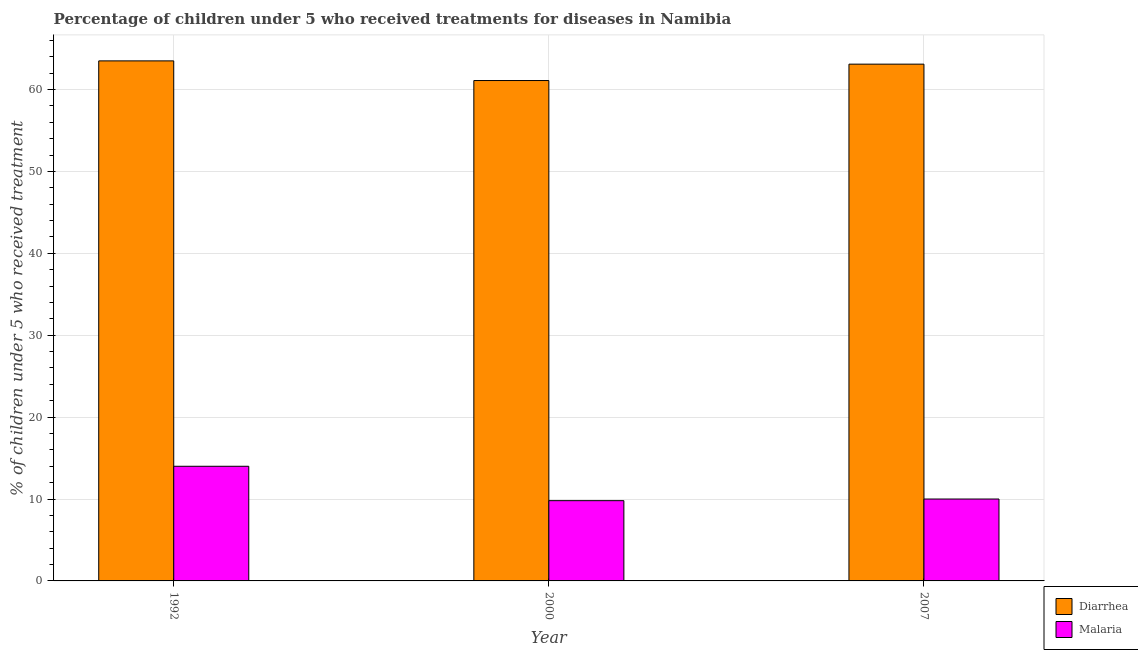How many different coloured bars are there?
Your answer should be very brief. 2. How many groups of bars are there?
Offer a terse response. 3. Are the number of bars per tick equal to the number of legend labels?
Your response must be concise. Yes. Are the number of bars on each tick of the X-axis equal?
Make the answer very short. Yes. What is the label of the 2nd group of bars from the left?
Ensure brevity in your answer.  2000. What is the percentage of children who received treatment for diarrhoea in 2000?
Your answer should be compact. 61.1. Across all years, what is the maximum percentage of children who received treatment for diarrhoea?
Keep it short and to the point. 63.5. Across all years, what is the minimum percentage of children who received treatment for diarrhoea?
Offer a terse response. 61.1. What is the total percentage of children who received treatment for diarrhoea in the graph?
Provide a short and direct response. 187.7. What is the difference between the percentage of children who received treatment for diarrhoea in 1992 and that in 2000?
Offer a terse response. 2.4. What is the difference between the percentage of children who received treatment for malaria in 2000 and the percentage of children who received treatment for diarrhoea in 1992?
Keep it short and to the point. -4.2. What is the average percentage of children who received treatment for diarrhoea per year?
Ensure brevity in your answer.  62.57. In the year 2007, what is the difference between the percentage of children who received treatment for malaria and percentage of children who received treatment for diarrhoea?
Provide a short and direct response. 0. In how many years, is the percentage of children who received treatment for diarrhoea greater than 4 %?
Your response must be concise. 3. What is the ratio of the percentage of children who received treatment for diarrhoea in 1992 to that in 2000?
Keep it short and to the point. 1.04. What is the difference between the highest and the second highest percentage of children who received treatment for diarrhoea?
Give a very brief answer. 0.4. What is the difference between the highest and the lowest percentage of children who received treatment for diarrhoea?
Ensure brevity in your answer.  2.4. In how many years, is the percentage of children who received treatment for malaria greater than the average percentage of children who received treatment for malaria taken over all years?
Your answer should be compact. 1. What does the 1st bar from the left in 2007 represents?
Your response must be concise. Diarrhea. What does the 2nd bar from the right in 2007 represents?
Provide a succinct answer. Diarrhea. Are all the bars in the graph horizontal?
Offer a terse response. No. How many years are there in the graph?
Offer a very short reply. 3. What is the difference between two consecutive major ticks on the Y-axis?
Offer a very short reply. 10. Are the values on the major ticks of Y-axis written in scientific E-notation?
Give a very brief answer. No. How many legend labels are there?
Offer a terse response. 2. How are the legend labels stacked?
Provide a succinct answer. Vertical. What is the title of the graph?
Offer a terse response. Percentage of children under 5 who received treatments for diseases in Namibia. Does "Lower secondary education" appear as one of the legend labels in the graph?
Your answer should be compact. No. What is the label or title of the X-axis?
Provide a short and direct response. Year. What is the label or title of the Y-axis?
Make the answer very short. % of children under 5 who received treatment. What is the % of children under 5 who received treatment of Diarrhea in 1992?
Keep it short and to the point. 63.5. What is the % of children under 5 who received treatment in Malaria in 1992?
Ensure brevity in your answer.  14. What is the % of children under 5 who received treatment of Diarrhea in 2000?
Provide a succinct answer. 61.1. What is the % of children under 5 who received treatment of Diarrhea in 2007?
Offer a terse response. 63.1. Across all years, what is the maximum % of children under 5 who received treatment in Diarrhea?
Offer a terse response. 63.5. Across all years, what is the minimum % of children under 5 who received treatment of Diarrhea?
Ensure brevity in your answer.  61.1. Across all years, what is the minimum % of children under 5 who received treatment in Malaria?
Ensure brevity in your answer.  9.8. What is the total % of children under 5 who received treatment in Diarrhea in the graph?
Your answer should be compact. 187.7. What is the total % of children under 5 who received treatment in Malaria in the graph?
Your answer should be very brief. 33.8. What is the difference between the % of children under 5 who received treatment in Diarrhea in 1992 and that in 2000?
Give a very brief answer. 2.4. What is the difference between the % of children under 5 who received treatment of Diarrhea in 1992 and that in 2007?
Ensure brevity in your answer.  0.4. What is the difference between the % of children under 5 who received treatment in Malaria in 2000 and that in 2007?
Your answer should be compact. -0.2. What is the difference between the % of children under 5 who received treatment of Diarrhea in 1992 and the % of children under 5 who received treatment of Malaria in 2000?
Offer a terse response. 53.7. What is the difference between the % of children under 5 who received treatment in Diarrhea in 1992 and the % of children under 5 who received treatment in Malaria in 2007?
Your answer should be very brief. 53.5. What is the difference between the % of children under 5 who received treatment in Diarrhea in 2000 and the % of children under 5 who received treatment in Malaria in 2007?
Give a very brief answer. 51.1. What is the average % of children under 5 who received treatment of Diarrhea per year?
Your answer should be compact. 62.57. What is the average % of children under 5 who received treatment in Malaria per year?
Keep it short and to the point. 11.27. In the year 1992, what is the difference between the % of children under 5 who received treatment in Diarrhea and % of children under 5 who received treatment in Malaria?
Keep it short and to the point. 49.5. In the year 2000, what is the difference between the % of children under 5 who received treatment in Diarrhea and % of children under 5 who received treatment in Malaria?
Your answer should be very brief. 51.3. In the year 2007, what is the difference between the % of children under 5 who received treatment of Diarrhea and % of children under 5 who received treatment of Malaria?
Your response must be concise. 53.1. What is the ratio of the % of children under 5 who received treatment of Diarrhea in 1992 to that in 2000?
Offer a very short reply. 1.04. What is the ratio of the % of children under 5 who received treatment of Malaria in 1992 to that in 2000?
Offer a terse response. 1.43. What is the ratio of the % of children under 5 who received treatment in Diarrhea in 2000 to that in 2007?
Provide a short and direct response. 0.97. What is the difference between the highest and the second highest % of children under 5 who received treatment of Diarrhea?
Keep it short and to the point. 0.4. What is the difference between the highest and the second highest % of children under 5 who received treatment of Malaria?
Give a very brief answer. 4. What is the difference between the highest and the lowest % of children under 5 who received treatment of Malaria?
Your answer should be compact. 4.2. 